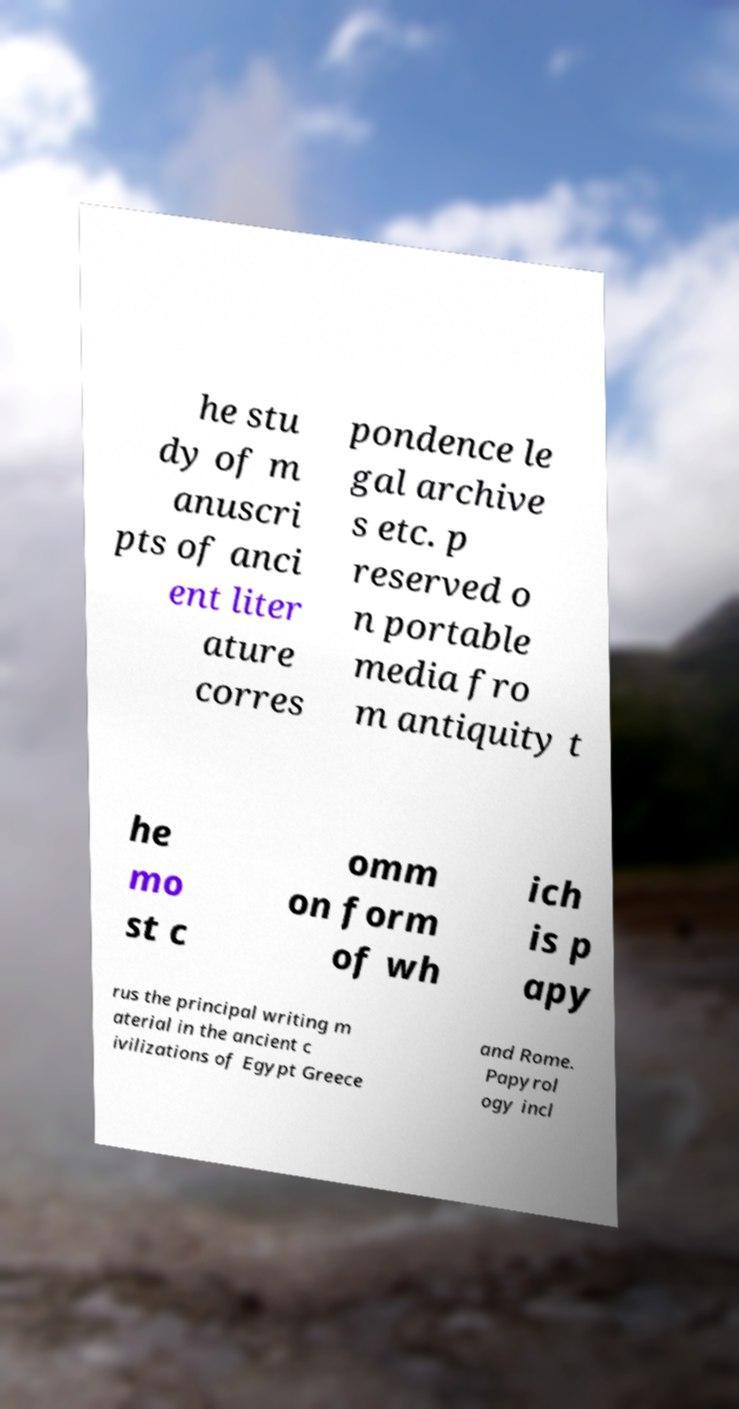Please identify and transcribe the text found in this image. he stu dy of m anuscri pts of anci ent liter ature corres pondence le gal archive s etc. p reserved o n portable media fro m antiquity t he mo st c omm on form of wh ich is p apy rus the principal writing m aterial in the ancient c ivilizations of Egypt Greece and Rome. Papyrol ogy incl 